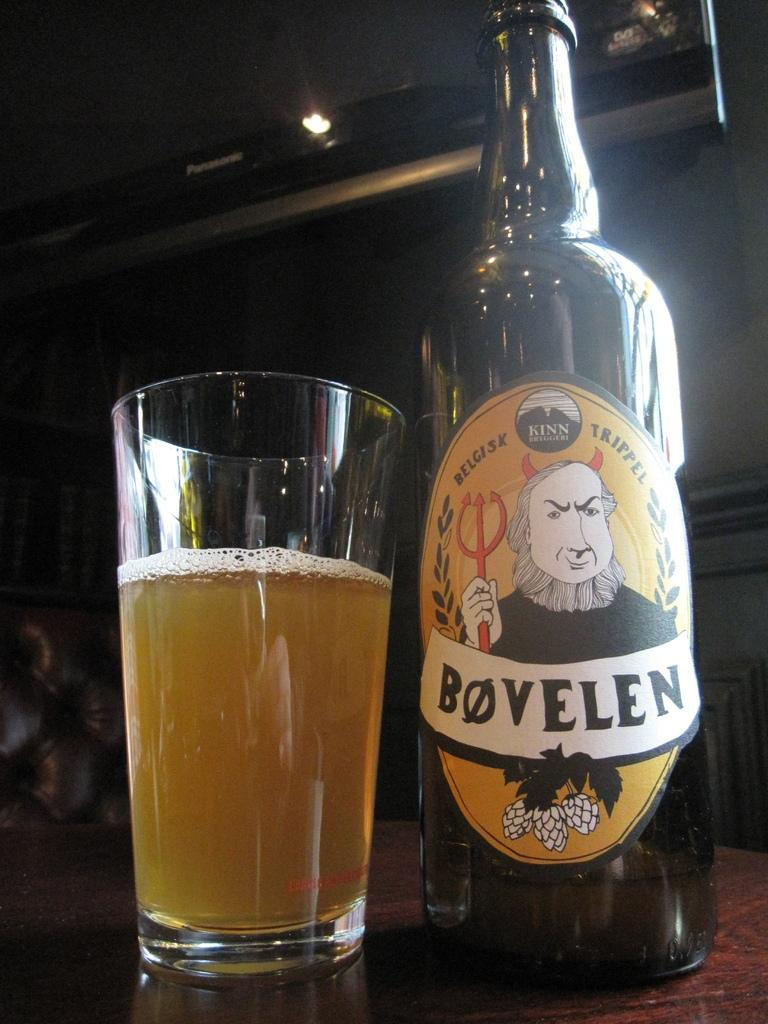What type of glass can be seen in the image? There is a wine glass in the image. What is located near the wine glass? There is a bottle in the image. What type of plantation is visible in the image? There is no plantation present in the image; it only features a wine glass and a bottle. What does the group need to do in order to enjoy the wine? The question assumes the presence of a group, which is not mentioned in the facts. The image only shows a wine glass and a bottle, so it cannot be determined what a group might need to do. 